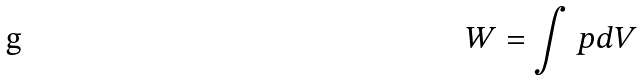<formula> <loc_0><loc_0><loc_500><loc_500>W = \int p d V</formula> 